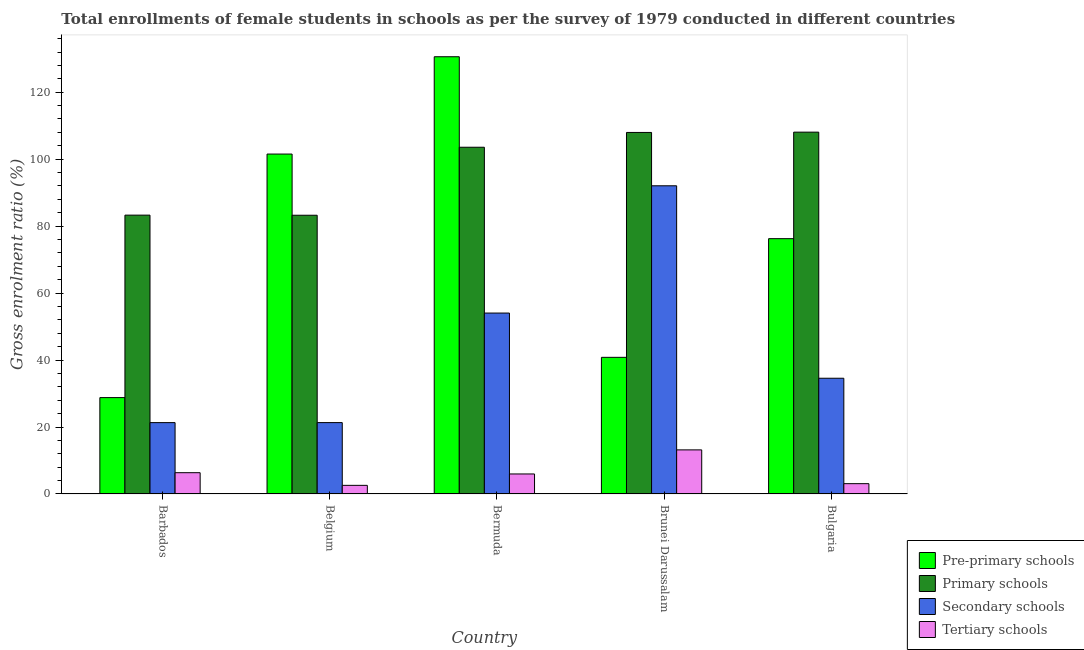How many different coloured bars are there?
Provide a short and direct response. 4. Are the number of bars on each tick of the X-axis equal?
Offer a terse response. Yes. What is the label of the 3rd group of bars from the left?
Your response must be concise. Bermuda. In how many cases, is the number of bars for a given country not equal to the number of legend labels?
Offer a very short reply. 0. What is the gross enrolment ratio(female) in primary schools in Belgium?
Offer a terse response. 83.25. Across all countries, what is the maximum gross enrolment ratio(female) in secondary schools?
Make the answer very short. 92.05. Across all countries, what is the minimum gross enrolment ratio(female) in tertiary schools?
Give a very brief answer. 2.58. In which country was the gross enrolment ratio(female) in secondary schools minimum?
Make the answer very short. Barbados. What is the total gross enrolment ratio(female) in primary schools in the graph?
Ensure brevity in your answer.  486.14. What is the difference between the gross enrolment ratio(female) in primary schools in Bermuda and that in Bulgaria?
Your answer should be compact. -4.51. What is the difference between the gross enrolment ratio(female) in primary schools in Bulgaria and the gross enrolment ratio(female) in tertiary schools in Bermuda?
Ensure brevity in your answer.  102.09. What is the average gross enrolment ratio(female) in pre-primary schools per country?
Your response must be concise. 75.59. What is the difference between the gross enrolment ratio(female) in tertiary schools and gross enrolment ratio(female) in pre-primary schools in Bermuda?
Your answer should be compact. -124.62. In how many countries, is the gross enrolment ratio(female) in primary schools greater than 28 %?
Give a very brief answer. 5. What is the ratio of the gross enrolment ratio(female) in primary schools in Barbados to that in Brunei Darussalam?
Ensure brevity in your answer.  0.77. Is the gross enrolment ratio(female) in secondary schools in Brunei Darussalam less than that in Bulgaria?
Offer a terse response. No. Is the difference between the gross enrolment ratio(female) in tertiary schools in Belgium and Brunei Darussalam greater than the difference between the gross enrolment ratio(female) in primary schools in Belgium and Brunei Darussalam?
Provide a succinct answer. Yes. What is the difference between the highest and the second highest gross enrolment ratio(female) in pre-primary schools?
Keep it short and to the point. 29.07. What is the difference between the highest and the lowest gross enrolment ratio(female) in secondary schools?
Give a very brief answer. 70.74. In how many countries, is the gross enrolment ratio(female) in pre-primary schools greater than the average gross enrolment ratio(female) in pre-primary schools taken over all countries?
Provide a short and direct response. 3. Is the sum of the gross enrolment ratio(female) in secondary schools in Belgium and Bulgaria greater than the maximum gross enrolment ratio(female) in pre-primary schools across all countries?
Offer a terse response. No. Is it the case that in every country, the sum of the gross enrolment ratio(female) in tertiary schools and gross enrolment ratio(female) in pre-primary schools is greater than the sum of gross enrolment ratio(female) in primary schools and gross enrolment ratio(female) in secondary schools?
Keep it short and to the point. No. What does the 2nd bar from the left in Brunei Darussalam represents?
Provide a succinct answer. Primary schools. What does the 4th bar from the right in Barbados represents?
Your answer should be very brief. Pre-primary schools. Is it the case that in every country, the sum of the gross enrolment ratio(female) in pre-primary schools and gross enrolment ratio(female) in primary schools is greater than the gross enrolment ratio(female) in secondary schools?
Your response must be concise. Yes. Are all the bars in the graph horizontal?
Make the answer very short. No. Where does the legend appear in the graph?
Your response must be concise. Bottom right. How are the legend labels stacked?
Offer a terse response. Vertical. What is the title of the graph?
Offer a terse response. Total enrollments of female students in schools as per the survey of 1979 conducted in different countries. What is the Gross enrolment ratio (%) of Pre-primary schools in Barbados?
Keep it short and to the point. 28.78. What is the Gross enrolment ratio (%) in Primary schools in Barbados?
Make the answer very short. 83.28. What is the Gross enrolment ratio (%) in Secondary schools in Barbados?
Your answer should be compact. 21.31. What is the Gross enrolment ratio (%) of Tertiary schools in Barbados?
Offer a terse response. 6.35. What is the Gross enrolment ratio (%) in Pre-primary schools in Belgium?
Ensure brevity in your answer.  101.53. What is the Gross enrolment ratio (%) of Primary schools in Belgium?
Provide a succinct answer. 83.25. What is the Gross enrolment ratio (%) in Secondary schools in Belgium?
Your answer should be very brief. 21.32. What is the Gross enrolment ratio (%) of Tertiary schools in Belgium?
Your response must be concise. 2.58. What is the Gross enrolment ratio (%) of Pre-primary schools in Bermuda?
Give a very brief answer. 130.59. What is the Gross enrolment ratio (%) in Primary schools in Bermuda?
Provide a short and direct response. 103.56. What is the Gross enrolment ratio (%) in Secondary schools in Bermuda?
Make the answer very short. 54.04. What is the Gross enrolment ratio (%) of Tertiary schools in Bermuda?
Give a very brief answer. 5.98. What is the Gross enrolment ratio (%) in Pre-primary schools in Brunei Darussalam?
Your response must be concise. 40.81. What is the Gross enrolment ratio (%) of Primary schools in Brunei Darussalam?
Offer a very short reply. 107.98. What is the Gross enrolment ratio (%) in Secondary schools in Brunei Darussalam?
Your answer should be very brief. 92.05. What is the Gross enrolment ratio (%) of Tertiary schools in Brunei Darussalam?
Make the answer very short. 13.17. What is the Gross enrolment ratio (%) of Pre-primary schools in Bulgaria?
Your response must be concise. 76.26. What is the Gross enrolment ratio (%) in Primary schools in Bulgaria?
Give a very brief answer. 108.07. What is the Gross enrolment ratio (%) of Secondary schools in Bulgaria?
Keep it short and to the point. 34.56. What is the Gross enrolment ratio (%) in Tertiary schools in Bulgaria?
Make the answer very short. 3.08. Across all countries, what is the maximum Gross enrolment ratio (%) in Pre-primary schools?
Offer a very short reply. 130.59. Across all countries, what is the maximum Gross enrolment ratio (%) in Primary schools?
Ensure brevity in your answer.  108.07. Across all countries, what is the maximum Gross enrolment ratio (%) of Secondary schools?
Make the answer very short. 92.05. Across all countries, what is the maximum Gross enrolment ratio (%) in Tertiary schools?
Provide a short and direct response. 13.17. Across all countries, what is the minimum Gross enrolment ratio (%) of Pre-primary schools?
Provide a short and direct response. 28.78. Across all countries, what is the minimum Gross enrolment ratio (%) of Primary schools?
Give a very brief answer. 83.25. Across all countries, what is the minimum Gross enrolment ratio (%) in Secondary schools?
Make the answer very short. 21.31. Across all countries, what is the minimum Gross enrolment ratio (%) in Tertiary schools?
Provide a short and direct response. 2.58. What is the total Gross enrolment ratio (%) of Pre-primary schools in the graph?
Offer a very short reply. 377.97. What is the total Gross enrolment ratio (%) of Primary schools in the graph?
Your response must be concise. 486.14. What is the total Gross enrolment ratio (%) of Secondary schools in the graph?
Offer a very short reply. 223.28. What is the total Gross enrolment ratio (%) of Tertiary schools in the graph?
Ensure brevity in your answer.  31.15. What is the difference between the Gross enrolment ratio (%) in Pre-primary schools in Barbados and that in Belgium?
Provide a succinct answer. -72.74. What is the difference between the Gross enrolment ratio (%) of Primary schools in Barbados and that in Belgium?
Your response must be concise. 0.03. What is the difference between the Gross enrolment ratio (%) in Secondary schools in Barbados and that in Belgium?
Provide a succinct answer. -0. What is the difference between the Gross enrolment ratio (%) of Tertiary schools in Barbados and that in Belgium?
Provide a succinct answer. 3.78. What is the difference between the Gross enrolment ratio (%) in Pre-primary schools in Barbados and that in Bermuda?
Ensure brevity in your answer.  -101.81. What is the difference between the Gross enrolment ratio (%) of Primary schools in Barbados and that in Bermuda?
Your answer should be compact. -20.28. What is the difference between the Gross enrolment ratio (%) in Secondary schools in Barbados and that in Bermuda?
Provide a short and direct response. -32.73. What is the difference between the Gross enrolment ratio (%) of Tertiary schools in Barbados and that in Bermuda?
Your answer should be compact. 0.38. What is the difference between the Gross enrolment ratio (%) in Pre-primary schools in Barbados and that in Brunei Darussalam?
Ensure brevity in your answer.  -12.03. What is the difference between the Gross enrolment ratio (%) of Primary schools in Barbados and that in Brunei Darussalam?
Give a very brief answer. -24.7. What is the difference between the Gross enrolment ratio (%) in Secondary schools in Barbados and that in Brunei Darussalam?
Offer a terse response. -70.74. What is the difference between the Gross enrolment ratio (%) in Tertiary schools in Barbados and that in Brunei Darussalam?
Keep it short and to the point. -6.81. What is the difference between the Gross enrolment ratio (%) of Pre-primary schools in Barbados and that in Bulgaria?
Your answer should be very brief. -47.47. What is the difference between the Gross enrolment ratio (%) of Primary schools in Barbados and that in Bulgaria?
Ensure brevity in your answer.  -24.79. What is the difference between the Gross enrolment ratio (%) of Secondary schools in Barbados and that in Bulgaria?
Offer a very short reply. -13.25. What is the difference between the Gross enrolment ratio (%) of Tertiary schools in Barbados and that in Bulgaria?
Your response must be concise. 3.28. What is the difference between the Gross enrolment ratio (%) in Pre-primary schools in Belgium and that in Bermuda?
Offer a very short reply. -29.07. What is the difference between the Gross enrolment ratio (%) of Primary schools in Belgium and that in Bermuda?
Keep it short and to the point. -20.31. What is the difference between the Gross enrolment ratio (%) of Secondary schools in Belgium and that in Bermuda?
Give a very brief answer. -32.72. What is the difference between the Gross enrolment ratio (%) of Tertiary schools in Belgium and that in Bermuda?
Your response must be concise. -3.4. What is the difference between the Gross enrolment ratio (%) in Pre-primary schools in Belgium and that in Brunei Darussalam?
Offer a very short reply. 60.71. What is the difference between the Gross enrolment ratio (%) of Primary schools in Belgium and that in Brunei Darussalam?
Your response must be concise. -24.73. What is the difference between the Gross enrolment ratio (%) of Secondary schools in Belgium and that in Brunei Darussalam?
Your answer should be very brief. -70.73. What is the difference between the Gross enrolment ratio (%) in Tertiary schools in Belgium and that in Brunei Darussalam?
Your answer should be compact. -10.59. What is the difference between the Gross enrolment ratio (%) of Pre-primary schools in Belgium and that in Bulgaria?
Your answer should be very brief. 25.27. What is the difference between the Gross enrolment ratio (%) of Primary schools in Belgium and that in Bulgaria?
Provide a succinct answer. -24.82. What is the difference between the Gross enrolment ratio (%) of Secondary schools in Belgium and that in Bulgaria?
Provide a succinct answer. -13.25. What is the difference between the Gross enrolment ratio (%) of Tertiary schools in Belgium and that in Bulgaria?
Provide a short and direct response. -0.5. What is the difference between the Gross enrolment ratio (%) of Pre-primary schools in Bermuda and that in Brunei Darussalam?
Your answer should be compact. 89.78. What is the difference between the Gross enrolment ratio (%) in Primary schools in Bermuda and that in Brunei Darussalam?
Keep it short and to the point. -4.42. What is the difference between the Gross enrolment ratio (%) of Secondary schools in Bermuda and that in Brunei Darussalam?
Provide a short and direct response. -38.01. What is the difference between the Gross enrolment ratio (%) of Tertiary schools in Bermuda and that in Brunei Darussalam?
Keep it short and to the point. -7.19. What is the difference between the Gross enrolment ratio (%) in Pre-primary schools in Bermuda and that in Bulgaria?
Your response must be concise. 54.34. What is the difference between the Gross enrolment ratio (%) in Primary schools in Bermuda and that in Bulgaria?
Offer a very short reply. -4.51. What is the difference between the Gross enrolment ratio (%) of Secondary schools in Bermuda and that in Bulgaria?
Ensure brevity in your answer.  19.47. What is the difference between the Gross enrolment ratio (%) of Tertiary schools in Bermuda and that in Bulgaria?
Offer a very short reply. 2.9. What is the difference between the Gross enrolment ratio (%) in Pre-primary schools in Brunei Darussalam and that in Bulgaria?
Your answer should be compact. -35.44. What is the difference between the Gross enrolment ratio (%) in Primary schools in Brunei Darussalam and that in Bulgaria?
Offer a very short reply. -0.09. What is the difference between the Gross enrolment ratio (%) of Secondary schools in Brunei Darussalam and that in Bulgaria?
Keep it short and to the point. 57.49. What is the difference between the Gross enrolment ratio (%) in Tertiary schools in Brunei Darussalam and that in Bulgaria?
Make the answer very short. 10.09. What is the difference between the Gross enrolment ratio (%) of Pre-primary schools in Barbados and the Gross enrolment ratio (%) of Primary schools in Belgium?
Your answer should be compact. -54.47. What is the difference between the Gross enrolment ratio (%) in Pre-primary schools in Barbados and the Gross enrolment ratio (%) in Secondary schools in Belgium?
Ensure brevity in your answer.  7.47. What is the difference between the Gross enrolment ratio (%) of Pre-primary schools in Barbados and the Gross enrolment ratio (%) of Tertiary schools in Belgium?
Give a very brief answer. 26.21. What is the difference between the Gross enrolment ratio (%) in Primary schools in Barbados and the Gross enrolment ratio (%) in Secondary schools in Belgium?
Keep it short and to the point. 61.97. What is the difference between the Gross enrolment ratio (%) in Primary schools in Barbados and the Gross enrolment ratio (%) in Tertiary schools in Belgium?
Your answer should be compact. 80.71. What is the difference between the Gross enrolment ratio (%) of Secondary schools in Barbados and the Gross enrolment ratio (%) of Tertiary schools in Belgium?
Your answer should be very brief. 18.74. What is the difference between the Gross enrolment ratio (%) of Pre-primary schools in Barbados and the Gross enrolment ratio (%) of Primary schools in Bermuda?
Your response must be concise. -74.78. What is the difference between the Gross enrolment ratio (%) in Pre-primary schools in Barbados and the Gross enrolment ratio (%) in Secondary schools in Bermuda?
Give a very brief answer. -25.25. What is the difference between the Gross enrolment ratio (%) of Pre-primary schools in Barbados and the Gross enrolment ratio (%) of Tertiary schools in Bermuda?
Ensure brevity in your answer.  22.81. What is the difference between the Gross enrolment ratio (%) in Primary schools in Barbados and the Gross enrolment ratio (%) in Secondary schools in Bermuda?
Provide a succinct answer. 29.24. What is the difference between the Gross enrolment ratio (%) of Primary schools in Barbados and the Gross enrolment ratio (%) of Tertiary schools in Bermuda?
Make the answer very short. 77.3. What is the difference between the Gross enrolment ratio (%) in Secondary schools in Barbados and the Gross enrolment ratio (%) in Tertiary schools in Bermuda?
Offer a very short reply. 15.34. What is the difference between the Gross enrolment ratio (%) of Pre-primary schools in Barbados and the Gross enrolment ratio (%) of Primary schools in Brunei Darussalam?
Offer a very short reply. -79.2. What is the difference between the Gross enrolment ratio (%) in Pre-primary schools in Barbados and the Gross enrolment ratio (%) in Secondary schools in Brunei Darussalam?
Keep it short and to the point. -63.27. What is the difference between the Gross enrolment ratio (%) of Pre-primary schools in Barbados and the Gross enrolment ratio (%) of Tertiary schools in Brunei Darussalam?
Your response must be concise. 15.62. What is the difference between the Gross enrolment ratio (%) in Primary schools in Barbados and the Gross enrolment ratio (%) in Secondary schools in Brunei Darussalam?
Your response must be concise. -8.77. What is the difference between the Gross enrolment ratio (%) in Primary schools in Barbados and the Gross enrolment ratio (%) in Tertiary schools in Brunei Darussalam?
Your answer should be very brief. 70.11. What is the difference between the Gross enrolment ratio (%) in Secondary schools in Barbados and the Gross enrolment ratio (%) in Tertiary schools in Brunei Darussalam?
Provide a succinct answer. 8.14. What is the difference between the Gross enrolment ratio (%) of Pre-primary schools in Barbados and the Gross enrolment ratio (%) of Primary schools in Bulgaria?
Your answer should be compact. -79.28. What is the difference between the Gross enrolment ratio (%) of Pre-primary schools in Barbados and the Gross enrolment ratio (%) of Secondary schools in Bulgaria?
Make the answer very short. -5.78. What is the difference between the Gross enrolment ratio (%) of Pre-primary schools in Barbados and the Gross enrolment ratio (%) of Tertiary schools in Bulgaria?
Make the answer very short. 25.71. What is the difference between the Gross enrolment ratio (%) in Primary schools in Barbados and the Gross enrolment ratio (%) in Secondary schools in Bulgaria?
Your response must be concise. 48.72. What is the difference between the Gross enrolment ratio (%) of Primary schools in Barbados and the Gross enrolment ratio (%) of Tertiary schools in Bulgaria?
Ensure brevity in your answer.  80.21. What is the difference between the Gross enrolment ratio (%) in Secondary schools in Barbados and the Gross enrolment ratio (%) in Tertiary schools in Bulgaria?
Your answer should be compact. 18.24. What is the difference between the Gross enrolment ratio (%) in Pre-primary schools in Belgium and the Gross enrolment ratio (%) in Primary schools in Bermuda?
Your answer should be compact. -2.03. What is the difference between the Gross enrolment ratio (%) of Pre-primary schools in Belgium and the Gross enrolment ratio (%) of Secondary schools in Bermuda?
Make the answer very short. 47.49. What is the difference between the Gross enrolment ratio (%) of Pre-primary schools in Belgium and the Gross enrolment ratio (%) of Tertiary schools in Bermuda?
Provide a succinct answer. 95.55. What is the difference between the Gross enrolment ratio (%) of Primary schools in Belgium and the Gross enrolment ratio (%) of Secondary schools in Bermuda?
Your answer should be very brief. 29.21. What is the difference between the Gross enrolment ratio (%) in Primary schools in Belgium and the Gross enrolment ratio (%) in Tertiary schools in Bermuda?
Make the answer very short. 77.27. What is the difference between the Gross enrolment ratio (%) in Secondary schools in Belgium and the Gross enrolment ratio (%) in Tertiary schools in Bermuda?
Keep it short and to the point. 15.34. What is the difference between the Gross enrolment ratio (%) of Pre-primary schools in Belgium and the Gross enrolment ratio (%) of Primary schools in Brunei Darussalam?
Offer a very short reply. -6.46. What is the difference between the Gross enrolment ratio (%) of Pre-primary schools in Belgium and the Gross enrolment ratio (%) of Secondary schools in Brunei Darussalam?
Your answer should be compact. 9.48. What is the difference between the Gross enrolment ratio (%) of Pre-primary schools in Belgium and the Gross enrolment ratio (%) of Tertiary schools in Brunei Darussalam?
Your response must be concise. 88.36. What is the difference between the Gross enrolment ratio (%) of Primary schools in Belgium and the Gross enrolment ratio (%) of Secondary schools in Brunei Darussalam?
Provide a short and direct response. -8.8. What is the difference between the Gross enrolment ratio (%) of Primary schools in Belgium and the Gross enrolment ratio (%) of Tertiary schools in Brunei Darussalam?
Provide a succinct answer. 70.08. What is the difference between the Gross enrolment ratio (%) in Secondary schools in Belgium and the Gross enrolment ratio (%) in Tertiary schools in Brunei Darussalam?
Your answer should be compact. 8.15. What is the difference between the Gross enrolment ratio (%) in Pre-primary schools in Belgium and the Gross enrolment ratio (%) in Primary schools in Bulgaria?
Your answer should be compact. -6.54. What is the difference between the Gross enrolment ratio (%) of Pre-primary schools in Belgium and the Gross enrolment ratio (%) of Secondary schools in Bulgaria?
Give a very brief answer. 66.96. What is the difference between the Gross enrolment ratio (%) in Pre-primary schools in Belgium and the Gross enrolment ratio (%) in Tertiary schools in Bulgaria?
Make the answer very short. 98.45. What is the difference between the Gross enrolment ratio (%) of Primary schools in Belgium and the Gross enrolment ratio (%) of Secondary schools in Bulgaria?
Your answer should be very brief. 48.69. What is the difference between the Gross enrolment ratio (%) of Primary schools in Belgium and the Gross enrolment ratio (%) of Tertiary schools in Bulgaria?
Give a very brief answer. 80.17. What is the difference between the Gross enrolment ratio (%) in Secondary schools in Belgium and the Gross enrolment ratio (%) in Tertiary schools in Bulgaria?
Offer a terse response. 18.24. What is the difference between the Gross enrolment ratio (%) of Pre-primary schools in Bermuda and the Gross enrolment ratio (%) of Primary schools in Brunei Darussalam?
Your answer should be very brief. 22.61. What is the difference between the Gross enrolment ratio (%) of Pre-primary schools in Bermuda and the Gross enrolment ratio (%) of Secondary schools in Brunei Darussalam?
Your response must be concise. 38.54. What is the difference between the Gross enrolment ratio (%) of Pre-primary schools in Bermuda and the Gross enrolment ratio (%) of Tertiary schools in Brunei Darussalam?
Your answer should be very brief. 117.43. What is the difference between the Gross enrolment ratio (%) in Primary schools in Bermuda and the Gross enrolment ratio (%) in Secondary schools in Brunei Darussalam?
Make the answer very short. 11.51. What is the difference between the Gross enrolment ratio (%) in Primary schools in Bermuda and the Gross enrolment ratio (%) in Tertiary schools in Brunei Darussalam?
Your answer should be very brief. 90.39. What is the difference between the Gross enrolment ratio (%) in Secondary schools in Bermuda and the Gross enrolment ratio (%) in Tertiary schools in Brunei Darussalam?
Make the answer very short. 40.87. What is the difference between the Gross enrolment ratio (%) in Pre-primary schools in Bermuda and the Gross enrolment ratio (%) in Primary schools in Bulgaria?
Provide a short and direct response. 22.53. What is the difference between the Gross enrolment ratio (%) in Pre-primary schools in Bermuda and the Gross enrolment ratio (%) in Secondary schools in Bulgaria?
Make the answer very short. 96.03. What is the difference between the Gross enrolment ratio (%) of Pre-primary schools in Bermuda and the Gross enrolment ratio (%) of Tertiary schools in Bulgaria?
Provide a short and direct response. 127.52. What is the difference between the Gross enrolment ratio (%) in Primary schools in Bermuda and the Gross enrolment ratio (%) in Secondary schools in Bulgaria?
Ensure brevity in your answer.  69. What is the difference between the Gross enrolment ratio (%) of Primary schools in Bermuda and the Gross enrolment ratio (%) of Tertiary schools in Bulgaria?
Ensure brevity in your answer.  100.48. What is the difference between the Gross enrolment ratio (%) of Secondary schools in Bermuda and the Gross enrolment ratio (%) of Tertiary schools in Bulgaria?
Make the answer very short. 50.96. What is the difference between the Gross enrolment ratio (%) in Pre-primary schools in Brunei Darussalam and the Gross enrolment ratio (%) in Primary schools in Bulgaria?
Make the answer very short. -67.26. What is the difference between the Gross enrolment ratio (%) in Pre-primary schools in Brunei Darussalam and the Gross enrolment ratio (%) in Secondary schools in Bulgaria?
Give a very brief answer. 6.25. What is the difference between the Gross enrolment ratio (%) of Pre-primary schools in Brunei Darussalam and the Gross enrolment ratio (%) of Tertiary schools in Bulgaria?
Keep it short and to the point. 37.73. What is the difference between the Gross enrolment ratio (%) of Primary schools in Brunei Darussalam and the Gross enrolment ratio (%) of Secondary schools in Bulgaria?
Your answer should be very brief. 73.42. What is the difference between the Gross enrolment ratio (%) in Primary schools in Brunei Darussalam and the Gross enrolment ratio (%) in Tertiary schools in Bulgaria?
Your answer should be very brief. 104.91. What is the difference between the Gross enrolment ratio (%) in Secondary schools in Brunei Darussalam and the Gross enrolment ratio (%) in Tertiary schools in Bulgaria?
Your answer should be compact. 88.97. What is the average Gross enrolment ratio (%) in Pre-primary schools per country?
Ensure brevity in your answer.  75.59. What is the average Gross enrolment ratio (%) of Primary schools per country?
Your response must be concise. 97.23. What is the average Gross enrolment ratio (%) of Secondary schools per country?
Give a very brief answer. 44.66. What is the average Gross enrolment ratio (%) of Tertiary schools per country?
Make the answer very short. 6.23. What is the difference between the Gross enrolment ratio (%) in Pre-primary schools and Gross enrolment ratio (%) in Primary schools in Barbados?
Your answer should be very brief. -54.5. What is the difference between the Gross enrolment ratio (%) in Pre-primary schools and Gross enrolment ratio (%) in Secondary schools in Barbados?
Your answer should be compact. 7.47. What is the difference between the Gross enrolment ratio (%) in Pre-primary schools and Gross enrolment ratio (%) in Tertiary schools in Barbados?
Offer a very short reply. 22.43. What is the difference between the Gross enrolment ratio (%) in Primary schools and Gross enrolment ratio (%) in Secondary schools in Barbados?
Make the answer very short. 61.97. What is the difference between the Gross enrolment ratio (%) of Primary schools and Gross enrolment ratio (%) of Tertiary schools in Barbados?
Offer a terse response. 76.93. What is the difference between the Gross enrolment ratio (%) of Secondary schools and Gross enrolment ratio (%) of Tertiary schools in Barbados?
Offer a very short reply. 14.96. What is the difference between the Gross enrolment ratio (%) of Pre-primary schools and Gross enrolment ratio (%) of Primary schools in Belgium?
Your answer should be compact. 18.27. What is the difference between the Gross enrolment ratio (%) in Pre-primary schools and Gross enrolment ratio (%) in Secondary schools in Belgium?
Give a very brief answer. 80.21. What is the difference between the Gross enrolment ratio (%) in Pre-primary schools and Gross enrolment ratio (%) in Tertiary schools in Belgium?
Make the answer very short. 98.95. What is the difference between the Gross enrolment ratio (%) in Primary schools and Gross enrolment ratio (%) in Secondary schools in Belgium?
Offer a very short reply. 61.94. What is the difference between the Gross enrolment ratio (%) of Primary schools and Gross enrolment ratio (%) of Tertiary schools in Belgium?
Give a very brief answer. 80.68. What is the difference between the Gross enrolment ratio (%) of Secondary schools and Gross enrolment ratio (%) of Tertiary schools in Belgium?
Offer a terse response. 18.74. What is the difference between the Gross enrolment ratio (%) in Pre-primary schools and Gross enrolment ratio (%) in Primary schools in Bermuda?
Your answer should be compact. 27.03. What is the difference between the Gross enrolment ratio (%) in Pre-primary schools and Gross enrolment ratio (%) in Secondary schools in Bermuda?
Your answer should be compact. 76.56. What is the difference between the Gross enrolment ratio (%) in Pre-primary schools and Gross enrolment ratio (%) in Tertiary schools in Bermuda?
Make the answer very short. 124.62. What is the difference between the Gross enrolment ratio (%) of Primary schools and Gross enrolment ratio (%) of Secondary schools in Bermuda?
Your answer should be compact. 49.52. What is the difference between the Gross enrolment ratio (%) of Primary schools and Gross enrolment ratio (%) of Tertiary schools in Bermuda?
Give a very brief answer. 97.58. What is the difference between the Gross enrolment ratio (%) of Secondary schools and Gross enrolment ratio (%) of Tertiary schools in Bermuda?
Your answer should be compact. 48.06. What is the difference between the Gross enrolment ratio (%) in Pre-primary schools and Gross enrolment ratio (%) in Primary schools in Brunei Darussalam?
Provide a short and direct response. -67.17. What is the difference between the Gross enrolment ratio (%) in Pre-primary schools and Gross enrolment ratio (%) in Secondary schools in Brunei Darussalam?
Keep it short and to the point. -51.24. What is the difference between the Gross enrolment ratio (%) in Pre-primary schools and Gross enrolment ratio (%) in Tertiary schools in Brunei Darussalam?
Your response must be concise. 27.64. What is the difference between the Gross enrolment ratio (%) in Primary schools and Gross enrolment ratio (%) in Secondary schools in Brunei Darussalam?
Keep it short and to the point. 15.93. What is the difference between the Gross enrolment ratio (%) in Primary schools and Gross enrolment ratio (%) in Tertiary schools in Brunei Darussalam?
Give a very brief answer. 94.81. What is the difference between the Gross enrolment ratio (%) in Secondary schools and Gross enrolment ratio (%) in Tertiary schools in Brunei Darussalam?
Ensure brevity in your answer.  78.88. What is the difference between the Gross enrolment ratio (%) in Pre-primary schools and Gross enrolment ratio (%) in Primary schools in Bulgaria?
Your answer should be compact. -31.81. What is the difference between the Gross enrolment ratio (%) of Pre-primary schools and Gross enrolment ratio (%) of Secondary schools in Bulgaria?
Your answer should be compact. 41.69. What is the difference between the Gross enrolment ratio (%) of Pre-primary schools and Gross enrolment ratio (%) of Tertiary schools in Bulgaria?
Give a very brief answer. 73.18. What is the difference between the Gross enrolment ratio (%) of Primary schools and Gross enrolment ratio (%) of Secondary schools in Bulgaria?
Offer a very short reply. 73.5. What is the difference between the Gross enrolment ratio (%) of Primary schools and Gross enrolment ratio (%) of Tertiary schools in Bulgaria?
Offer a terse response. 104.99. What is the difference between the Gross enrolment ratio (%) of Secondary schools and Gross enrolment ratio (%) of Tertiary schools in Bulgaria?
Provide a succinct answer. 31.49. What is the ratio of the Gross enrolment ratio (%) in Pre-primary schools in Barbados to that in Belgium?
Give a very brief answer. 0.28. What is the ratio of the Gross enrolment ratio (%) in Tertiary schools in Barbados to that in Belgium?
Your answer should be compact. 2.47. What is the ratio of the Gross enrolment ratio (%) of Pre-primary schools in Barbados to that in Bermuda?
Your answer should be compact. 0.22. What is the ratio of the Gross enrolment ratio (%) in Primary schools in Barbados to that in Bermuda?
Provide a short and direct response. 0.8. What is the ratio of the Gross enrolment ratio (%) in Secondary schools in Barbados to that in Bermuda?
Give a very brief answer. 0.39. What is the ratio of the Gross enrolment ratio (%) in Tertiary schools in Barbados to that in Bermuda?
Provide a short and direct response. 1.06. What is the ratio of the Gross enrolment ratio (%) in Pre-primary schools in Barbados to that in Brunei Darussalam?
Give a very brief answer. 0.71. What is the ratio of the Gross enrolment ratio (%) of Primary schools in Barbados to that in Brunei Darussalam?
Provide a succinct answer. 0.77. What is the ratio of the Gross enrolment ratio (%) in Secondary schools in Barbados to that in Brunei Darussalam?
Your answer should be very brief. 0.23. What is the ratio of the Gross enrolment ratio (%) in Tertiary schools in Barbados to that in Brunei Darussalam?
Offer a very short reply. 0.48. What is the ratio of the Gross enrolment ratio (%) in Pre-primary schools in Barbados to that in Bulgaria?
Keep it short and to the point. 0.38. What is the ratio of the Gross enrolment ratio (%) of Primary schools in Barbados to that in Bulgaria?
Offer a very short reply. 0.77. What is the ratio of the Gross enrolment ratio (%) of Secondary schools in Barbados to that in Bulgaria?
Keep it short and to the point. 0.62. What is the ratio of the Gross enrolment ratio (%) of Tertiary schools in Barbados to that in Bulgaria?
Your answer should be very brief. 2.07. What is the ratio of the Gross enrolment ratio (%) in Pre-primary schools in Belgium to that in Bermuda?
Ensure brevity in your answer.  0.78. What is the ratio of the Gross enrolment ratio (%) of Primary schools in Belgium to that in Bermuda?
Ensure brevity in your answer.  0.8. What is the ratio of the Gross enrolment ratio (%) of Secondary schools in Belgium to that in Bermuda?
Provide a short and direct response. 0.39. What is the ratio of the Gross enrolment ratio (%) of Tertiary schools in Belgium to that in Bermuda?
Keep it short and to the point. 0.43. What is the ratio of the Gross enrolment ratio (%) in Pre-primary schools in Belgium to that in Brunei Darussalam?
Keep it short and to the point. 2.49. What is the ratio of the Gross enrolment ratio (%) in Primary schools in Belgium to that in Brunei Darussalam?
Ensure brevity in your answer.  0.77. What is the ratio of the Gross enrolment ratio (%) in Secondary schools in Belgium to that in Brunei Darussalam?
Give a very brief answer. 0.23. What is the ratio of the Gross enrolment ratio (%) in Tertiary schools in Belgium to that in Brunei Darussalam?
Make the answer very short. 0.2. What is the ratio of the Gross enrolment ratio (%) of Pre-primary schools in Belgium to that in Bulgaria?
Your answer should be very brief. 1.33. What is the ratio of the Gross enrolment ratio (%) in Primary schools in Belgium to that in Bulgaria?
Provide a short and direct response. 0.77. What is the ratio of the Gross enrolment ratio (%) of Secondary schools in Belgium to that in Bulgaria?
Ensure brevity in your answer.  0.62. What is the ratio of the Gross enrolment ratio (%) of Tertiary schools in Belgium to that in Bulgaria?
Offer a terse response. 0.84. What is the ratio of the Gross enrolment ratio (%) of Pre-primary schools in Bermuda to that in Brunei Darussalam?
Your response must be concise. 3.2. What is the ratio of the Gross enrolment ratio (%) in Primary schools in Bermuda to that in Brunei Darussalam?
Make the answer very short. 0.96. What is the ratio of the Gross enrolment ratio (%) in Secondary schools in Bermuda to that in Brunei Darussalam?
Keep it short and to the point. 0.59. What is the ratio of the Gross enrolment ratio (%) of Tertiary schools in Bermuda to that in Brunei Darussalam?
Offer a very short reply. 0.45. What is the ratio of the Gross enrolment ratio (%) of Pre-primary schools in Bermuda to that in Bulgaria?
Offer a very short reply. 1.71. What is the ratio of the Gross enrolment ratio (%) of Secondary schools in Bermuda to that in Bulgaria?
Give a very brief answer. 1.56. What is the ratio of the Gross enrolment ratio (%) of Tertiary schools in Bermuda to that in Bulgaria?
Your answer should be very brief. 1.94. What is the ratio of the Gross enrolment ratio (%) of Pre-primary schools in Brunei Darussalam to that in Bulgaria?
Keep it short and to the point. 0.54. What is the ratio of the Gross enrolment ratio (%) of Primary schools in Brunei Darussalam to that in Bulgaria?
Keep it short and to the point. 1. What is the ratio of the Gross enrolment ratio (%) in Secondary schools in Brunei Darussalam to that in Bulgaria?
Keep it short and to the point. 2.66. What is the ratio of the Gross enrolment ratio (%) in Tertiary schools in Brunei Darussalam to that in Bulgaria?
Offer a terse response. 4.28. What is the difference between the highest and the second highest Gross enrolment ratio (%) in Pre-primary schools?
Provide a short and direct response. 29.07. What is the difference between the highest and the second highest Gross enrolment ratio (%) in Primary schools?
Your answer should be very brief. 0.09. What is the difference between the highest and the second highest Gross enrolment ratio (%) in Secondary schools?
Offer a very short reply. 38.01. What is the difference between the highest and the second highest Gross enrolment ratio (%) in Tertiary schools?
Provide a succinct answer. 6.81. What is the difference between the highest and the lowest Gross enrolment ratio (%) in Pre-primary schools?
Your answer should be very brief. 101.81. What is the difference between the highest and the lowest Gross enrolment ratio (%) of Primary schools?
Provide a short and direct response. 24.82. What is the difference between the highest and the lowest Gross enrolment ratio (%) in Secondary schools?
Your response must be concise. 70.74. What is the difference between the highest and the lowest Gross enrolment ratio (%) in Tertiary schools?
Give a very brief answer. 10.59. 